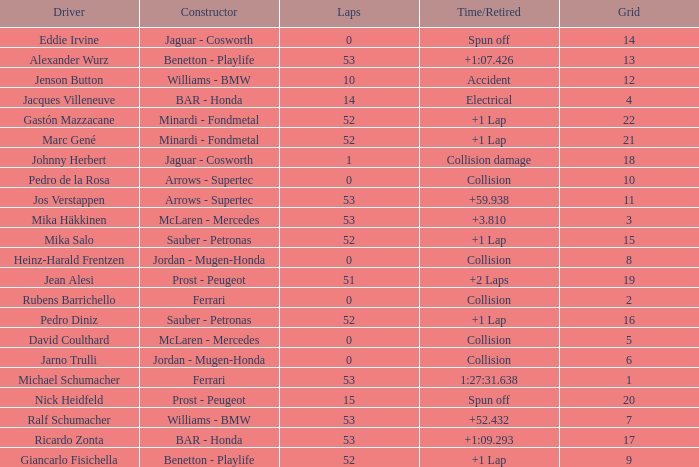What is the grid number with less than 52 laps and a Time/Retired of collision, and a Constructor of arrows - supertec? 1.0. 